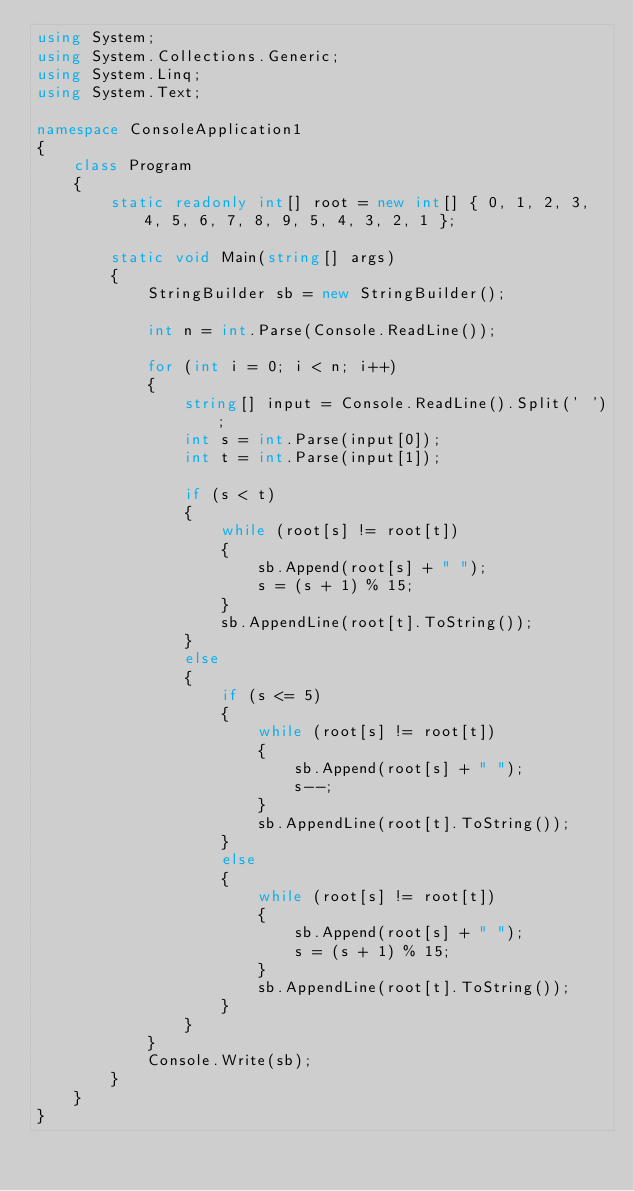<code> <loc_0><loc_0><loc_500><loc_500><_C#_>using System;
using System.Collections.Generic;
using System.Linq;
using System.Text;

namespace ConsoleApplication1
{
    class Program
    {
        static readonly int[] root = new int[] { 0, 1, 2, 3, 4, 5, 6, 7, 8, 9, 5, 4, 3, 2, 1 };

        static void Main(string[] args)
        {
            StringBuilder sb = new StringBuilder();

            int n = int.Parse(Console.ReadLine());

            for (int i = 0; i < n; i++)
            {
                string[] input = Console.ReadLine().Split(' ');
                int s = int.Parse(input[0]);
                int t = int.Parse(input[1]);

                if (s < t)
                {
                    while (root[s] != root[t])
                    {
                        sb.Append(root[s] + " ");
                        s = (s + 1) % 15;
                    }
                    sb.AppendLine(root[t].ToString());
                }
                else
                {
                    if (s <= 5)
                    {
                        while (root[s] != root[t])
                        {
                            sb.Append(root[s] + " ");
                            s--;
                        }
                        sb.AppendLine(root[t].ToString());
                    }
                    else
                    {
                        while (root[s] != root[t])
                        {
                            sb.Append(root[s] + " ");
                            s = (s + 1) % 15;
                        }
                        sb.AppendLine(root[t].ToString());
                    }
                }
            }
            Console.Write(sb);
        }
    }
}</code> 